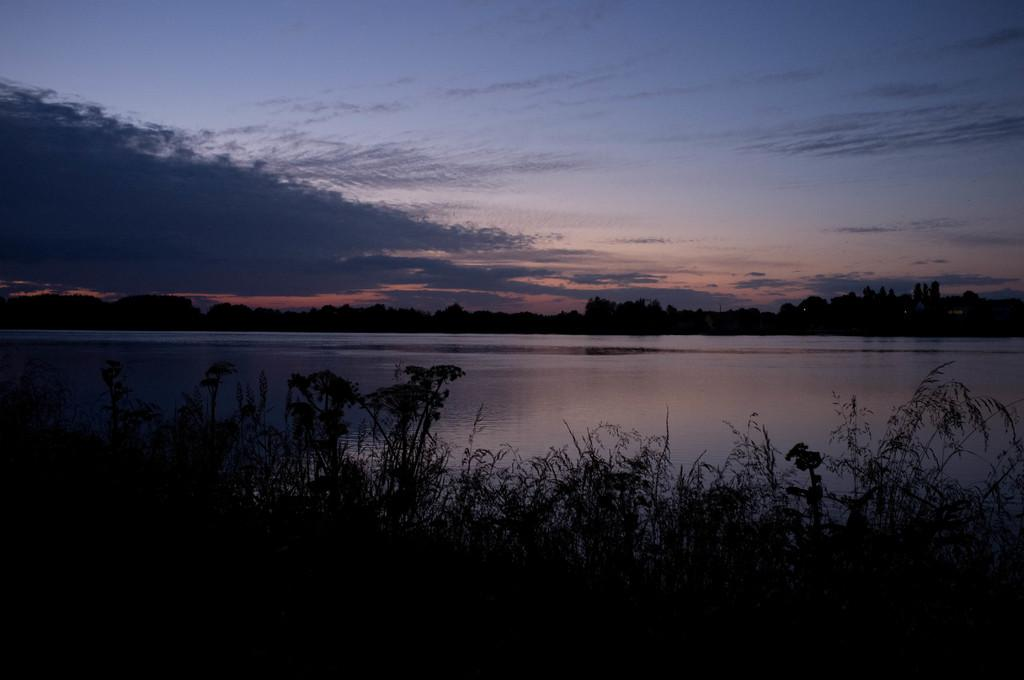What can be seen in the foreground of the picture? There are plants and trees in the foreground of the picture. What is located in the center of the picture? There is a water body in the center of the picture. What is visible in the background of the picture? There are trees in the background of the picture. What can be seen at the top of the picture? The sky is visible at the top of the picture. Can you see any bricks or windows in the picture? There are no bricks or windows present in the image. Are there any people swimming in the water body in the picture? There is no indication of people swimming in the water body in the image. 